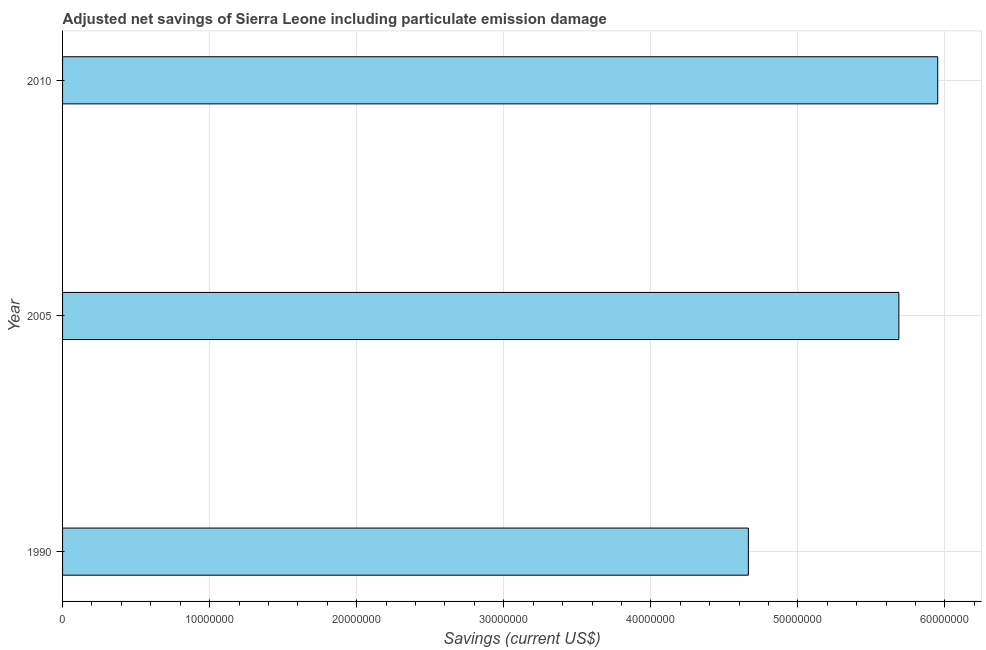Does the graph contain any zero values?
Make the answer very short. No. What is the title of the graph?
Offer a terse response. Adjusted net savings of Sierra Leone including particulate emission damage. What is the label or title of the X-axis?
Make the answer very short. Savings (current US$). What is the adjusted net savings in 2010?
Keep it short and to the point. 5.95e+07. Across all years, what is the maximum adjusted net savings?
Your response must be concise. 5.95e+07. Across all years, what is the minimum adjusted net savings?
Ensure brevity in your answer.  4.66e+07. In which year was the adjusted net savings maximum?
Provide a short and direct response. 2010. What is the sum of the adjusted net savings?
Ensure brevity in your answer.  1.63e+08. What is the difference between the adjusted net savings in 1990 and 2005?
Provide a succinct answer. -1.02e+07. What is the average adjusted net savings per year?
Keep it short and to the point. 5.43e+07. What is the median adjusted net savings?
Provide a short and direct response. 5.69e+07. What is the ratio of the adjusted net savings in 1990 to that in 2010?
Ensure brevity in your answer.  0.78. Is the adjusted net savings in 1990 less than that in 2010?
Provide a succinct answer. Yes. Is the difference between the adjusted net savings in 1990 and 2005 greater than the difference between any two years?
Offer a terse response. No. What is the difference between the highest and the second highest adjusted net savings?
Provide a succinct answer. 2.64e+06. What is the difference between the highest and the lowest adjusted net savings?
Ensure brevity in your answer.  1.29e+07. In how many years, is the adjusted net savings greater than the average adjusted net savings taken over all years?
Give a very brief answer. 2. Are all the bars in the graph horizontal?
Offer a terse response. Yes. What is the Savings (current US$) in 1990?
Ensure brevity in your answer.  4.66e+07. What is the Savings (current US$) of 2005?
Provide a short and direct response. 5.69e+07. What is the Savings (current US$) of 2010?
Keep it short and to the point. 5.95e+07. What is the difference between the Savings (current US$) in 1990 and 2005?
Make the answer very short. -1.02e+07. What is the difference between the Savings (current US$) in 1990 and 2010?
Your response must be concise. -1.29e+07. What is the difference between the Savings (current US$) in 2005 and 2010?
Ensure brevity in your answer.  -2.64e+06. What is the ratio of the Savings (current US$) in 1990 to that in 2005?
Offer a terse response. 0.82. What is the ratio of the Savings (current US$) in 1990 to that in 2010?
Ensure brevity in your answer.  0.78. What is the ratio of the Savings (current US$) in 2005 to that in 2010?
Give a very brief answer. 0.96. 